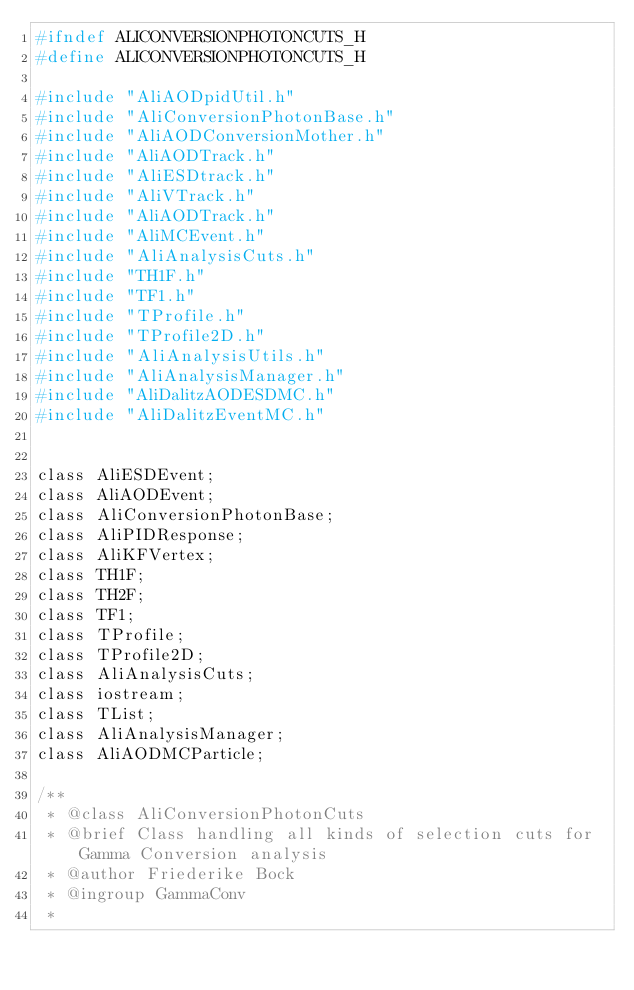<code> <loc_0><loc_0><loc_500><loc_500><_C_>#ifndef ALICONVERSIONPHOTONCUTS_H
#define ALICONVERSIONPHOTONCUTS_H

#include "AliAODpidUtil.h"
#include "AliConversionPhotonBase.h"
#include "AliAODConversionMother.h"
#include "AliAODTrack.h"
#include "AliESDtrack.h"
#include "AliVTrack.h"
#include "AliAODTrack.h"
#include "AliMCEvent.h"
#include "AliAnalysisCuts.h"
#include "TH1F.h"
#include "TF1.h"
#include "TProfile.h"
#include "TProfile2D.h"
#include "AliAnalysisUtils.h"
#include "AliAnalysisManager.h"
#include "AliDalitzAODESDMC.h"
#include "AliDalitzEventMC.h"


class AliESDEvent;
class AliAODEvent;
class AliConversionPhotonBase;
class AliPIDResponse;
class AliKFVertex;
class TH1F;
class TH2F;
class TF1;
class TProfile;
class TProfile2D;
class AliAnalysisCuts;
class iostream;
class TList;
class AliAnalysisManager;
class AliAODMCParticle;

/**
 * @class AliConversionPhotonCuts
 * @brief Class handling all kinds of selection cuts for Gamma Conversion analysis
 * @author Friederike Bock
 * @ingroup GammaConv
 *</code> 